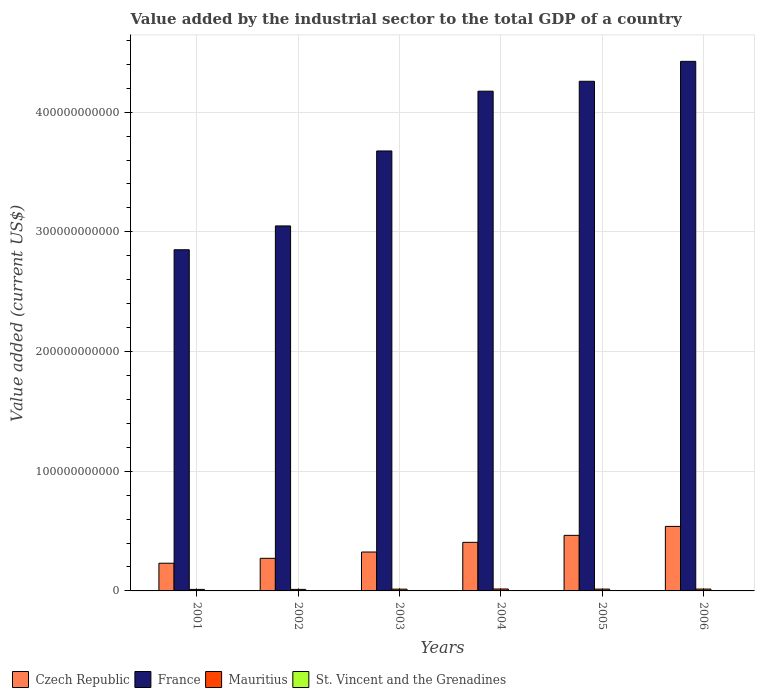How many different coloured bars are there?
Give a very brief answer. 4. What is the value added by the industrial sector to the total GDP in St. Vincent and the Grenadines in 2001?
Make the answer very short. 7.24e+07. Across all years, what is the maximum value added by the industrial sector to the total GDP in St. Vincent and the Grenadines?
Offer a very short reply. 1.00e+08. Across all years, what is the minimum value added by the industrial sector to the total GDP in Czech Republic?
Provide a succinct answer. 2.31e+1. What is the total value added by the industrial sector to the total GDP in Mauritius in the graph?
Ensure brevity in your answer.  8.70e+09. What is the difference between the value added by the industrial sector to the total GDP in Mauritius in 2005 and that in 2006?
Provide a succinct answer. -2.73e+07. What is the difference between the value added by the industrial sector to the total GDP in France in 2003 and the value added by the industrial sector to the total GDP in Czech Republic in 2004?
Ensure brevity in your answer.  3.27e+11. What is the average value added by the industrial sector to the total GDP in France per year?
Offer a very short reply. 3.74e+11. In the year 2002, what is the difference between the value added by the industrial sector to the total GDP in St. Vincent and the Grenadines and value added by the industrial sector to the total GDP in Mauritius?
Offer a very short reply. -1.21e+09. In how many years, is the value added by the industrial sector to the total GDP in Czech Republic greater than 40000000000 US$?
Your answer should be very brief. 3. What is the ratio of the value added by the industrial sector to the total GDP in Czech Republic in 2001 to that in 2004?
Keep it short and to the point. 0.57. What is the difference between the highest and the second highest value added by the industrial sector to the total GDP in Mauritius?
Make the answer very short. 7.12e+07. What is the difference between the highest and the lowest value added by the industrial sector to the total GDP in St. Vincent and the Grenadines?
Your answer should be very brief. 2.84e+07. Is the sum of the value added by the industrial sector to the total GDP in France in 2003 and 2005 greater than the maximum value added by the industrial sector to the total GDP in St. Vincent and the Grenadines across all years?
Keep it short and to the point. Yes. What does the 4th bar from the left in 2002 represents?
Your response must be concise. St. Vincent and the Grenadines. What does the 1st bar from the right in 2004 represents?
Your response must be concise. St. Vincent and the Grenadines. How many bars are there?
Provide a short and direct response. 24. What is the difference between two consecutive major ticks on the Y-axis?
Ensure brevity in your answer.  1.00e+11. Does the graph contain grids?
Provide a short and direct response. Yes. Where does the legend appear in the graph?
Ensure brevity in your answer.  Bottom left. How many legend labels are there?
Offer a very short reply. 4. What is the title of the graph?
Your response must be concise. Value added by the industrial sector to the total GDP of a country. Does "Bosnia and Herzegovina" appear as one of the legend labels in the graph?
Ensure brevity in your answer.  No. What is the label or title of the X-axis?
Offer a very short reply. Years. What is the label or title of the Y-axis?
Make the answer very short. Value added (current US$). What is the Value added (current US$) in Czech Republic in 2001?
Give a very brief answer. 2.31e+1. What is the Value added (current US$) in France in 2001?
Your response must be concise. 2.85e+11. What is the Value added (current US$) in Mauritius in 2001?
Offer a very short reply. 1.26e+09. What is the Value added (current US$) of St. Vincent and the Grenadines in 2001?
Offer a very short reply. 7.24e+07. What is the Value added (current US$) in Czech Republic in 2002?
Make the answer very short. 2.72e+1. What is the Value added (current US$) in France in 2002?
Your response must be concise. 3.05e+11. What is the Value added (current US$) in Mauritius in 2002?
Make the answer very short. 1.28e+09. What is the Value added (current US$) of St. Vincent and the Grenadines in 2002?
Keep it short and to the point. 7.20e+07. What is the Value added (current US$) in Czech Republic in 2003?
Ensure brevity in your answer.  3.25e+1. What is the Value added (current US$) of France in 2003?
Ensure brevity in your answer.  3.68e+11. What is the Value added (current US$) of Mauritius in 2003?
Your answer should be compact. 1.48e+09. What is the Value added (current US$) of St. Vincent and the Grenadines in 2003?
Give a very brief answer. 7.81e+07. What is the Value added (current US$) of Czech Republic in 2004?
Offer a very short reply. 4.06e+1. What is the Value added (current US$) of France in 2004?
Provide a short and direct response. 4.18e+11. What is the Value added (current US$) of Mauritius in 2004?
Give a very brief answer. 1.61e+09. What is the Value added (current US$) of St. Vincent and the Grenadines in 2004?
Provide a short and direct response. 8.77e+07. What is the Value added (current US$) of Czech Republic in 2005?
Provide a short and direct response. 4.64e+1. What is the Value added (current US$) of France in 2005?
Give a very brief answer. 4.26e+11. What is the Value added (current US$) in Mauritius in 2005?
Ensure brevity in your answer.  1.52e+09. What is the Value added (current US$) in St. Vincent and the Grenadines in 2005?
Give a very brief answer. 9.02e+07. What is the Value added (current US$) in Czech Republic in 2006?
Your response must be concise. 5.39e+1. What is the Value added (current US$) in France in 2006?
Offer a very short reply. 4.42e+11. What is the Value added (current US$) of Mauritius in 2006?
Offer a terse response. 1.54e+09. What is the Value added (current US$) in St. Vincent and the Grenadines in 2006?
Give a very brief answer. 1.00e+08. Across all years, what is the maximum Value added (current US$) in Czech Republic?
Make the answer very short. 5.39e+1. Across all years, what is the maximum Value added (current US$) in France?
Provide a succinct answer. 4.42e+11. Across all years, what is the maximum Value added (current US$) of Mauritius?
Offer a terse response. 1.61e+09. Across all years, what is the maximum Value added (current US$) in St. Vincent and the Grenadines?
Your answer should be very brief. 1.00e+08. Across all years, what is the minimum Value added (current US$) in Czech Republic?
Give a very brief answer. 2.31e+1. Across all years, what is the minimum Value added (current US$) in France?
Provide a succinct answer. 2.85e+11. Across all years, what is the minimum Value added (current US$) in Mauritius?
Provide a succinct answer. 1.26e+09. Across all years, what is the minimum Value added (current US$) of St. Vincent and the Grenadines?
Make the answer very short. 7.20e+07. What is the total Value added (current US$) in Czech Republic in the graph?
Your response must be concise. 2.24e+11. What is the total Value added (current US$) of France in the graph?
Provide a short and direct response. 2.24e+12. What is the total Value added (current US$) of Mauritius in the graph?
Your answer should be very brief. 8.70e+09. What is the total Value added (current US$) in St. Vincent and the Grenadines in the graph?
Offer a very short reply. 5.01e+08. What is the difference between the Value added (current US$) of Czech Republic in 2001 and that in 2002?
Give a very brief answer. -4.10e+09. What is the difference between the Value added (current US$) of France in 2001 and that in 2002?
Your response must be concise. -1.99e+1. What is the difference between the Value added (current US$) of Mauritius in 2001 and that in 2002?
Keep it short and to the point. -2.63e+07. What is the difference between the Value added (current US$) in St. Vincent and the Grenadines in 2001 and that in 2002?
Your answer should be compact. 4.23e+05. What is the difference between the Value added (current US$) in Czech Republic in 2001 and that in 2003?
Ensure brevity in your answer.  -9.36e+09. What is the difference between the Value added (current US$) in France in 2001 and that in 2003?
Your answer should be compact. -8.25e+1. What is the difference between the Value added (current US$) in Mauritius in 2001 and that in 2003?
Your response must be concise. -2.26e+08. What is the difference between the Value added (current US$) of St. Vincent and the Grenadines in 2001 and that in 2003?
Give a very brief answer. -5.65e+06. What is the difference between the Value added (current US$) in Czech Republic in 2001 and that in 2004?
Give a very brief answer. -1.75e+1. What is the difference between the Value added (current US$) in France in 2001 and that in 2004?
Provide a short and direct response. -1.32e+11. What is the difference between the Value added (current US$) in Mauritius in 2001 and that in 2004?
Your answer should be very brief. -3.57e+08. What is the difference between the Value added (current US$) in St. Vincent and the Grenadines in 2001 and that in 2004?
Offer a terse response. -1.53e+07. What is the difference between the Value added (current US$) in Czech Republic in 2001 and that in 2005?
Offer a very short reply. -2.33e+1. What is the difference between the Value added (current US$) in France in 2001 and that in 2005?
Make the answer very short. -1.41e+11. What is the difference between the Value added (current US$) in Mauritius in 2001 and that in 2005?
Provide a succinct answer. -2.58e+08. What is the difference between the Value added (current US$) of St. Vincent and the Grenadines in 2001 and that in 2005?
Ensure brevity in your answer.  -1.78e+07. What is the difference between the Value added (current US$) of Czech Republic in 2001 and that in 2006?
Provide a succinct answer. -3.08e+1. What is the difference between the Value added (current US$) of France in 2001 and that in 2006?
Give a very brief answer. -1.57e+11. What is the difference between the Value added (current US$) in Mauritius in 2001 and that in 2006?
Keep it short and to the point. -2.85e+08. What is the difference between the Value added (current US$) of St. Vincent and the Grenadines in 2001 and that in 2006?
Make the answer very short. -2.80e+07. What is the difference between the Value added (current US$) in Czech Republic in 2002 and that in 2003?
Make the answer very short. -5.26e+09. What is the difference between the Value added (current US$) in France in 2002 and that in 2003?
Keep it short and to the point. -6.26e+1. What is the difference between the Value added (current US$) of Mauritius in 2002 and that in 2003?
Provide a succinct answer. -1.99e+08. What is the difference between the Value added (current US$) of St. Vincent and the Grenadines in 2002 and that in 2003?
Your answer should be very brief. -6.07e+06. What is the difference between the Value added (current US$) in Czech Republic in 2002 and that in 2004?
Your answer should be very brief. -1.34e+1. What is the difference between the Value added (current US$) of France in 2002 and that in 2004?
Make the answer very short. -1.13e+11. What is the difference between the Value added (current US$) of Mauritius in 2002 and that in 2004?
Keep it short and to the point. -3.30e+08. What is the difference between the Value added (current US$) of St. Vincent and the Grenadines in 2002 and that in 2004?
Offer a very short reply. -1.57e+07. What is the difference between the Value added (current US$) of Czech Republic in 2002 and that in 2005?
Provide a short and direct response. -1.92e+1. What is the difference between the Value added (current US$) in France in 2002 and that in 2005?
Ensure brevity in your answer.  -1.21e+11. What is the difference between the Value added (current US$) in Mauritius in 2002 and that in 2005?
Your answer should be compact. -2.32e+08. What is the difference between the Value added (current US$) in St. Vincent and the Grenadines in 2002 and that in 2005?
Ensure brevity in your answer.  -1.82e+07. What is the difference between the Value added (current US$) of Czech Republic in 2002 and that in 2006?
Your answer should be compact. -2.67e+1. What is the difference between the Value added (current US$) of France in 2002 and that in 2006?
Ensure brevity in your answer.  -1.38e+11. What is the difference between the Value added (current US$) of Mauritius in 2002 and that in 2006?
Offer a very short reply. -2.59e+08. What is the difference between the Value added (current US$) in St. Vincent and the Grenadines in 2002 and that in 2006?
Make the answer very short. -2.84e+07. What is the difference between the Value added (current US$) in Czech Republic in 2003 and that in 2004?
Your answer should be very brief. -8.10e+09. What is the difference between the Value added (current US$) in France in 2003 and that in 2004?
Provide a succinct answer. -5.00e+1. What is the difference between the Value added (current US$) of Mauritius in 2003 and that in 2004?
Provide a succinct answer. -1.31e+08. What is the difference between the Value added (current US$) in St. Vincent and the Grenadines in 2003 and that in 2004?
Provide a short and direct response. -9.62e+06. What is the difference between the Value added (current US$) in Czech Republic in 2003 and that in 2005?
Provide a short and direct response. -1.39e+1. What is the difference between the Value added (current US$) in France in 2003 and that in 2005?
Your response must be concise. -5.82e+1. What is the difference between the Value added (current US$) in Mauritius in 2003 and that in 2005?
Your answer should be very brief. -3.26e+07. What is the difference between the Value added (current US$) of St. Vincent and the Grenadines in 2003 and that in 2005?
Provide a succinct answer. -1.21e+07. What is the difference between the Value added (current US$) in Czech Republic in 2003 and that in 2006?
Provide a short and direct response. -2.14e+1. What is the difference between the Value added (current US$) of France in 2003 and that in 2006?
Give a very brief answer. -7.49e+1. What is the difference between the Value added (current US$) in Mauritius in 2003 and that in 2006?
Provide a succinct answer. -5.99e+07. What is the difference between the Value added (current US$) of St. Vincent and the Grenadines in 2003 and that in 2006?
Ensure brevity in your answer.  -2.23e+07. What is the difference between the Value added (current US$) in Czech Republic in 2004 and that in 2005?
Your answer should be compact. -5.83e+09. What is the difference between the Value added (current US$) of France in 2004 and that in 2005?
Ensure brevity in your answer.  -8.28e+09. What is the difference between the Value added (current US$) of Mauritius in 2004 and that in 2005?
Your answer should be compact. 9.86e+07. What is the difference between the Value added (current US$) in St. Vincent and the Grenadines in 2004 and that in 2005?
Your response must be concise. -2.53e+06. What is the difference between the Value added (current US$) of Czech Republic in 2004 and that in 2006?
Your answer should be compact. -1.33e+1. What is the difference between the Value added (current US$) of France in 2004 and that in 2006?
Provide a short and direct response. -2.49e+1. What is the difference between the Value added (current US$) of Mauritius in 2004 and that in 2006?
Provide a succinct answer. 7.12e+07. What is the difference between the Value added (current US$) in St. Vincent and the Grenadines in 2004 and that in 2006?
Your response must be concise. -1.27e+07. What is the difference between the Value added (current US$) in Czech Republic in 2005 and that in 2006?
Provide a short and direct response. -7.49e+09. What is the difference between the Value added (current US$) of France in 2005 and that in 2006?
Offer a terse response. -1.66e+1. What is the difference between the Value added (current US$) of Mauritius in 2005 and that in 2006?
Your response must be concise. -2.73e+07. What is the difference between the Value added (current US$) of St. Vincent and the Grenadines in 2005 and that in 2006?
Provide a short and direct response. -1.02e+07. What is the difference between the Value added (current US$) of Czech Republic in 2001 and the Value added (current US$) of France in 2002?
Your response must be concise. -2.82e+11. What is the difference between the Value added (current US$) of Czech Republic in 2001 and the Value added (current US$) of Mauritius in 2002?
Offer a terse response. 2.19e+1. What is the difference between the Value added (current US$) of Czech Republic in 2001 and the Value added (current US$) of St. Vincent and the Grenadines in 2002?
Your answer should be very brief. 2.31e+1. What is the difference between the Value added (current US$) in France in 2001 and the Value added (current US$) in Mauritius in 2002?
Offer a terse response. 2.84e+11. What is the difference between the Value added (current US$) of France in 2001 and the Value added (current US$) of St. Vincent and the Grenadines in 2002?
Your answer should be compact. 2.85e+11. What is the difference between the Value added (current US$) of Mauritius in 2001 and the Value added (current US$) of St. Vincent and the Grenadines in 2002?
Ensure brevity in your answer.  1.19e+09. What is the difference between the Value added (current US$) of Czech Republic in 2001 and the Value added (current US$) of France in 2003?
Offer a terse response. -3.44e+11. What is the difference between the Value added (current US$) of Czech Republic in 2001 and the Value added (current US$) of Mauritius in 2003?
Give a very brief answer. 2.17e+1. What is the difference between the Value added (current US$) of Czech Republic in 2001 and the Value added (current US$) of St. Vincent and the Grenadines in 2003?
Your response must be concise. 2.31e+1. What is the difference between the Value added (current US$) in France in 2001 and the Value added (current US$) in Mauritius in 2003?
Offer a very short reply. 2.84e+11. What is the difference between the Value added (current US$) in France in 2001 and the Value added (current US$) in St. Vincent and the Grenadines in 2003?
Offer a very short reply. 2.85e+11. What is the difference between the Value added (current US$) in Mauritius in 2001 and the Value added (current US$) in St. Vincent and the Grenadines in 2003?
Give a very brief answer. 1.18e+09. What is the difference between the Value added (current US$) of Czech Republic in 2001 and the Value added (current US$) of France in 2004?
Give a very brief answer. -3.94e+11. What is the difference between the Value added (current US$) in Czech Republic in 2001 and the Value added (current US$) in Mauritius in 2004?
Make the answer very short. 2.15e+1. What is the difference between the Value added (current US$) of Czech Republic in 2001 and the Value added (current US$) of St. Vincent and the Grenadines in 2004?
Offer a very short reply. 2.31e+1. What is the difference between the Value added (current US$) in France in 2001 and the Value added (current US$) in Mauritius in 2004?
Your answer should be very brief. 2.83e+11. What is the difference between the Value added (current US$) of France in 2001 and the Value added (current US$) of St. Vincent and the Grenadines in 2004?
Offer a very short reply. 2.85e+11. What is the difference between the Value added (current US$) in Mauritius in 2001 and the Value added (current US$) in St. Vincent and the Grenadines in 2004?
Offer a terse response. 1.17e+09. What is the difference between the Value added (current US$) in Czech Republic in 2001 and the Value added (current US$) in France in 2005?
Provide a succinct answer. -4.03e+11. What is the difference between the Value added (current US$) in Czech Republic in 2001 and the Value added (current US$) in Mauritius in 2005?
Ensure brevity in your answer.  2.16e+1. What is the difference between the Value added (current US$) of Czech Republic in 2001 and the Value added (current US$) of St. Vincent and the Grenadines in 2005?
Offer a terse response. 2.31e+1. What is the difference between the Value added (current US$) of France in 2001 and the Value added (current US$) of Mauritius in 2005?
Offer a terse response. 2.84e+11. What is the difference between the Value added (current US$) in France in 2001 and the Value added (current US$) in St. Vincent and the Grenadines in 2005?
Offer a very short reply. 2.85e+11. What is the difference between the Value added (current US$) of Mauritius in 2001 and the Value added (current US$) of St. Vincent and the Grenadines in 2005?
Ensure brevity in your answer.  1.17e+09. What is the difference between the Value added (current US$) of Czech Republic in 2001 and the Value added (current US$) of France in 2006?
Offer a very short reply. -4.19e+11. What is the difference between the Value added (current US$) in Czech Republic in 2001 and the Value added (current US$) in Mauritius in 2006?
Ensure brevity in your answer.  2.16e+1. What is the difference between the Value added (current US$) in Czech Republic in 2001 and the Value added (current US$) in St. Vincent and the Grenadines in 2006?
Provide a succinct answer. 2.30e+1. What is the difference between the Value added (current US$) in France in 2001 and the Value added (current US$) in Mauritius in 2006?
Provide a short and direct response. 2.84e+11. What is the difference between the Value added (current US$) in France in 2001 and the Value added (current US$) in St. Vincent and the Grenadines in 2006?
Offer a terse response. 2.85e+11. What is the difference between the Value added (current US$) of Mauritius in 2001 and the Value added (current US$) of St. Vincent and the Grenadines in 2006?
Keep it short and to the point. 1.16e+09. What is the difference between the Value added (current US$) in Czech Republic in 2002 and the Value added (current US$) in France in 2003?
Ensure brevity in your answer.  -3.40e+11. What is the difference between the Value added (current US$) in Czech Republic in 2002 and the Value added (current US$) in Mauritius in 2003?
Your answer should be very brief. 2.58e+1. What is the difference between the Value added (current US$) in Czech Republic in 2002 and the Value added (current US$) in St. Vincent and the Grenadines in 2003?
Offer a very short reply. 2.72e+1. What is the difference between the Value added (current US$) in France in 2002 and the Value added (current US$) in Mauritius in 2003?
Your answer should be very brief. 3.03e+11. What is the difference between the Value added (current US$) of France in 2002 and the Value added (current US$) of St. Vincent and the Grenadines in 2003?
Ensure brevity in your answer.  3.05e+11. What is the difference between the Value added (current US$) in Mauritius in 2002 and the Value added (current US$) in St. Vincent and the Grenadines in 2003?
Provide a short and direct response. 1.21e+09. What is the difference between the Value added (current US$) in Czech Republic in 2002 and the Value added (current US$) in France in 2004?
Offer a terse response. -3.90e+11. What is the difference between the Value added (current US$) in Czech Republic in 2002 and the Value added (current US$) in Mauritius in 2004?
Your response must be concise. 2.56e+1. What is the difference between the Value added (current US$) of Czech Republic in 2002 and the Value added (current US$) of St. Vincent and the Grenadines in 2004?
Your answer should be very brief. 2.72e+1. What is the difference between the Value added (current US$) in France in 2002 and the Value added (current US$) in Mauritius in 2004?
Your answer should be very brief. 3.03e+11. What is the difference between the Value added (current US$) of France in 2002 and the Value added (current US$) of St. Vincent and the Grenadines in 2004?
Give a very brief answer. 3.05e+11. What is the difference between the Value added (current US$) of Mauritius in 2002 and the Value added (current US$) of St. Vincent and the Grenadines in 2004?
Keep it short and to the point. 1.20e+09. What is the difference between the Value added (current US$) of Czech Republic in 2002 and the Value added (current US$) of France in 2005?
Provide a short and direct response. -3.99e+11. What is the difference between the Value added (current US$) of Czech Republic in 2002 and the Value added (current US$) of Mauritius in 2005?
Provide a succinct answer. 2.57e+1. What is the difference between the Value added (current US$) in Czech Republic in 2002 and the Value added (current US$) in St. Vincent and the Grenadines in 2005?
Your response must be concise. 2.71e+1. What is the difference between the Value added (current US$) of France in 2002 and the Value added (current US$) of Mauritius in 2005?
Provide a succinct answer. 3.03e+11. What is the difference between the Value added (current US$) in France in 2002 and the Value added (current US$) in St. Vincent and the Grenadines in 2005?
Offer a terse response. 3.05e+11. What is the difference between the Value added (current US$) of Mauritius in 2002 and the Value added (current US$) of St. Vincent and the Grenadines in 2005?
Ensure brevity in your answer.  1.19e+09. What is the difference between the Value added (current US$) in Czech Republic in 2002 and the Value added (current US$) in France in 2006?
Your response must be concise. -4.15e+11. What is the difference between the Value added (current US$) of Czech Republic in 2002 and the Value added (current US$) of Mauritius in 2006?
Offer a very short reply. 2.57e+1. What is the difference between the Value added (current US$) in Czech Republic in 2002 and the Value added (current US$) in St. Vincent and the Grenadines in 2006?
Provide a succinct answer. 2.71e+1. What is the difference between the Value added (current US$) in France in 2002 and the Value added (current US$) in Mauritius in 2006?
Keep it short and to the point. 3.03e+11. What is the difference between the Value added (current US$) in France in 2002 and the Value added (current US$) in St. Vincent and the Grenadines in 2006?
Provide a short and direct response. 3.05e+11. What is the difference between the Value added (current US$) of Mauritius in 2002 and the Value added (current US$) of St. Vincent and the Grenadines in 2006?
Your response must be concise. 1.18e+09. What is the difference between the Value added (current US$) of Czech Republic in 2003 and the Value added (current US$) of France in 2004?
Your answer should be very brief. -3.85e+11. What is the difference between the Value added (current US$) in Czech Republic in 2003 and the Value added (current US$) in Mauritius in 2004?
Make the answer very short. 3.09e+1. What is the difference between the Value added (current US$) in Czech Republic in 2003 and the Value added (current US$) in St. Vincent and the Grenadines in 2004?
Provide a succinct answer. 3.24e+1. What is the difference between the Value added (current US$) of France in 2003 and the Value added (current US$) of Mauritius in 2004?
Provide a short and direct response. 3.66e+11. What is the difference between the Value added (current US$) of France in 2003 and the Value added (current US$) of St. Vincent and the Grenadines in 2004?
Keep it short and to the point. 3.68e+11. What is the difference between the Value added (current US$) of Mauritius in 2003 and the Value added (current US$) of St. Vincent and the Grenadines in 2004?
Ensure brevity in your answer.  1.40e+09. What is the difference between the Value added (current US$) of Czech Republic in 2003 and the Value added (current US$) of France in 2005?
Your answer should be compact. -3.93e+11. What is the difference between the Value added (current US$) in Czech Republic in 2003 and the Value added (current US$) in Mauritius in 2005?
Make the answer very short. 3.10e+1. What is the difference between the Value added (current US$) in Czech Republic in 2003 and the Value added (current US$) in St. Vincent and the Grenadines in 2005?
Make the answer very short. 3.24e+1. What is the difference between the Value added (current US$) in France in 2003 and the Value added (current US$) in Mauritius in 2005?
Keep it short and to the point. 3.66e+11. What is the difference between the Value added (current US$) in France in 2003 and the Value added (current US$) in St. Vincent and the Grenadines in 2005?
Ensure brevity in your answer.  3.68e+11. What is the difference between the Value added (current US$) of Mauritius in 2003 and the Value added (current US$) of St. Vincent and the Grenadines in 2005?
Make the answer very short. 1.39e+09. What is the difference between the Value added (current US$) of Czech Republic in 2003 and the Value added (current US$) of France in 2006?
Make the answer very short. -4.10e+11. What is the difference between the Value added (current US$) in Czech Republic in 2003 and the Value added (current US$) in Mauritius in 2006?
Provide a succinct answer. 3.10e+1. What is the difference between the Value added (current US$) in Czech Republic in 2003 and the Value added (current US$) in St. Vincent and the Grenadines in 2006?
Provide a succinct answer. 3.24e+1. What is the difference between the Value added (current US$) of France in 2003 and the Value added (current US$) of Mauritius in 2006?
Offer a terse response. 3.66e+11. What is the difference between the Value added (current US$) of France in 2003 and the Value added (current US$) of St. Vincent and the Grenadines in 2006?
Ensure brevity in your answer.  3.67e+11. What is the difference between the Value added (current US$) in Mauritius in 2003 and the Value added (current US$) in St. Vincent and the Grenadines in 2006?
Provide a short and direct response. 1.38e+09. What is the difference between the Value added (current US$) in Czech Republic in 2004 and the Value added (current US$) in France in 2005?
Give a very brief answer. -3.85e+11. What is the difference between the Value added (current US$) in Czech Republic in 2004 and the Value added (current US$) in Mauritius in 2005?
Provide a short and direct response. 3.91e+1. What is the difference between the Value added (current US$) of Czech Republic in 2004 and the Value added (current US$) of St. Vincent and the Grenadines in 2005?
Provide a succinct answer. 4.05e+1. What is the difference between the Value added (current US$) in France in 2004 and the Value added (current US$) in Mauritius in 2005?
Your answer should be very brief. 4.16e+11. What is the difference between the Value added (current US$) in France in 2004 and the Value added (current US$) in St. Vincent and the Grenadines in 2005?
Give a very brief answer. 4.17e+11. What is the difference between the Value added (current US$) in Mauritius in 2004 and the Value added (current US$) in St. Vincent and the Grenadines in 2005?
Keep it short and to the point. 1.52e+09. What is the difference between the Value added (current US$) in Czech Republic in 2004 and the Value added (current US$) in France in 2006?
Your response must be concise. -4.02e+11. What is the difference between the Value added (current US$) in Czech Republic in 2004 and the Value added (current US$) in Mauritius in 2006?
Provide a short and direct response. 3.91e+1. What is the difference between the Value added (current US$) in Czech Republic in 2004 and the Value added (current US$) in St. Vincent and the Grenadines in 2006?
Provide a succinct answer. 4.05e+1. What is the difference between the Value added (current US$) of France in 2004 and the Value added (current US$) of Mauritius in 2006?
Offer a terse response. 4.16e+11. What is the difference between the Value added (current US$) in France in 2004 and the Value added (current US$) in St. Vincent and the Grenadines in 2006?
Give a very brief answer. 4.17e+11. What is the difference between the Value added (current US$) in Mauritius in 2004 and the Value added (current US$) in St. Vincent and the Grenadines in 2006?
Your answer should be very brief. 1.51e+09. What is the difference between the Value added (current US$) of Czech Republic in 2005 and the Value added (current US$) of France in 2006?
Offer a very short reply. -3.96e+11. What is the difference between the Value added (current US$) in Czech Republic in 2005 and the Value added (current US$) in Mauritius in 2006?
Keep it short and to the point. 4.49e+1. What is the difference between the Value added (current US$) in Czech Republic in 2005 and the Value added (current US$) in St. Vincent and the Grenadines in 2006?
Keep it short and to the point. 4.63e+1. What is the difference between the Value added (current US$) of France in 2005 and the Value added (current US$) of Mauritius in 2006?
Your answer should be very brief. 4.24e+11. What is the difference between the Value added (current US$) in France in 2005 and the Value added (current US$) in St. Vincent and the Grenadines in 2006?
Provide a short and direct response. 4.26e+11. What is the difference between the Value added (current US$) of Mauritius in 2005 and the Value added (current US$) of St. Vincent and the Grenadines in 2006?
Your answer should be compact. 1.42e+09. What is the average Value added (current US$) of Czech Republic per year?
Give a very brief answer. 3.73e+1. What is the average Value added (current US$) in France per year?
Offer a very short reply. 3.74e+11. What is the average Value added (current US$) of Mauritius per year?
Your answer should be compact. 1.45e+09. What is the average Value added (current US$) of St. Vincent and the Grenadines per year?
Your response must be concise. 8.35e+07. In the year 2001, what is the difference between the Value added (current US$) in Czech Republic and Value added (current US$) in France?
Offer a very short reply. -2.62e+11. In the year 2001, what is the difference between the Value added (current US$) of Czech Republic and Value added (current US$) of Mauritius?
Make the answer very short. 2.19e+1. In the year 2001, what is the difference between the Value added (current US$) of Czech Republic and Value added (current US$) of St. Vincent and the Grenadines?
Offer a terse response. 2.31e+1. In the year 2001, what is the difference between the Value added (current US$) of France and Value added (current US$) of Mauritius?
Your answer should be compact. 2.84e+11. In the year 2001, what is the difference between the Value added (current US$) in France and Value added (current US$) in St. Vincent and the Grenadines?
Provide a succinct answer. 2.85e+11. In the year 2001, what is the difference between the Value added (current US$) of Mauritius and Value added (current US$) of St. Vincent and the Grenadines?
Keep it short and to the point. 1.19e+09. In the year 2002, what is the difference between the Value added (current US$) of Czech Republic and Value added (current US$) of France?
Ensure brevity in your answer.  -2.78e+11. In the year 2002, what is the difference between the Value added (current US$) of Czech Republic and Value added (current US$) of Mauritius?
Your answer should be compact. 2.60e+1. In the year 2002, what is the difference between the Value added (current US$) in Czech Republic and Value added (current US$) in St. Vincent and the Grenadines?
Offer a terse response. 2.72e+1. In the year 2002, what is the difference between the Value added (current US$) in France and Value added (current US$) in Mauritius?
Provide a succinct answer. 3.04e+11. In the year 2002, what is the difference between the Value added (current US$) of France and Value added (current US$) of St. Vincent and the Grenadines?
Keep it short and to the point. 3.05e+11. In the year 2002, what is the difference between the Value added (current US$) in Mauritius and Value added (current US$) in St. Vincent and the Grenadines?
Your response must be concise. 1.21e+09. In the year 2003, what is the difference between the Value added (current US$) of Czech Republic and Value added (current US$) of France?
Your answer should be compact. -3.35e+11. In the year 2003, what is the difference between the Value added (current US$) of Czech Republic and Value added (current US$) of Mauritius?
Make the answer very short. 3.10e+1. In the year 2003, what is the difference between the Value added (current US$) in Czech Republic and Value added (current US$) in St. Vincent and the Grenadines?
Provide a short and direct response. 3.24e+1. In the year 2003, what is the difference between the Value added (current US$) of France and Value added (current US$) of Mauritius?
Provide a succinct answer. 3.66e+11. In the year 2003, what is the difference between the Value added (current US$) of France and Value added (current US$) of St. Vincent and the Grenadines?
Your answer should be compact. 3.68e+11. In the year 2003, what is the difference between the Value added (current US$) in Mauritius and Value added (current US$) in St. Vincent and the Grenadines?
Provide a succinct answer. 1.41e+09. In the year 2004, what is the difference between the Value added (current US$) of Czech Republic and Value added (current US$) of France?
Your answer should be very brief. -3.77e+11. In the year 2004, what is the difference between the Value added (current US$) of Czech Republic and Value added (current US$) of Mauritius?
Your response must be concise. 3.90e+1. In the year 2004, what is the difference between the Value added (current US$) of Czech Republic and Value added (current US$) of St. Vincent and the Grenadines?
Offer a very short reply. 4.05e+1. In the year 2004, what is the difference between the Value added (current US$) of France and Value added (current US$) of Mauritius?
Your answer should be compact. 4.16e+11. In the year 2004, what is the difference between the Value added (current US$) in France and Value added (current US$) in St. Vincent and the Grenadines?
Ensure brevity in your answer.  4.17e+11. In the year 2004, what is the difference between the Value added (current US$) of Mauritius and Value added (current US$) of St. Vincent and the Grenadines?
Give a very brief answer. 1.53e+09. In the year 2005, what is the difference between the Value added (current US$) of Czech Republic and Value added (current US$) of France?
Provide a succinct answer. -3.79e+11. In the year 2005, what is the difference between the Value added (current US$) in Czech Republic and Value added (current US$) in Mauritius?
Provide a short and direct response. 4.49e+1. In the year 2005, what is the difference between the Value added (current US$) in Czech Republic and Value added (current US$) in St. Vincent and the Grenadines?
Your answer should be compact. 4.63e+1. In the year 2005, what is the difference between the Value added (current US$) of France and Value added (current US$) of Mauritius?
Your answer should be compact. 4.24e+11. In the year 2005, what is the difference between the Value added (current US$) in France and Value added (current US$) in St. Vincent and the Grenadines?
Provide a succinct answer. 4.26e+11. In the year 2005, what is the difference between the Value added (current US$) of Mauritius and Value added (current US$) of St. Vincent and the Grenadines?
Provide a short and direct response. 1.43e+09. In the year 2006, what is the difference between the Value added (current US$) in Czech Republic and Value added (current US$) in France?
Provide a short and direct response. -3.89e+11. In the year 2006, what is the difference between the Value added (current US$) in Czech Republic and Value added (current US$) in Mauritius?
Make the answer very short. 5.24e+1. In the year 2006, what is the difference between the Value added (current US$) in Czech Republic and Value added (current US$) in St. Vincent and the Grenadines?
Provide a succinct answer. 5.38e+1. In the year 2006, what is the difference between the Value added (current US$) in France and Value added (current US$) in Mauritius?
Offer a very short reply. 4.41e+11. In the year 2006, what is the difference between the Value added (current US$) of France and Value added (current US$) of St. Vincent and the Grenadines?
Give a very brief answer. 4.42e+11. In the year 2006, what is the difference between the Value added (current US$) of Mauritius and Value added (current US$) of St. Vincent and the Grenadines?
Provide a short and direct response. 1.44e+09. What is the ratio of the Value added (current US$) in Czech Republic in 2001 to that in 2002?
Give a very brief answer. 0.85. What is the ratio of the Value added (current US$) of France in 2001 to that in 2002?
Keep it short and to the point. 0.93. What is the ratio of the Value added (current US$) of Mauritius in 2001 to that in 2002?
Your response must be concise. 0.98. What is the ratio of the Value added (current US$) of St. Vincent and the Grenadines in 2001 to that in 2002?
Give a very brief answer. 1.01. What is the ratio of the Value added (current US$) in Czech Republic in 2001 to that in 2003?
Your answer should be very brief. 0.71. What is the ratio of the Value added (current US$) of France in 2001 to that in 2003?
Provide a short and direct response. 0.78. What is the ratio of the Value added (current US$) of Mauritius in 2001 to that in 2003?
Provide a short and direct response. 0.85. What is the ratio of the Value added (current US$) in St. Vincent and the Grenadines in 2001 to that in 2003?
Offer a very short reply. 0.93. What is the ratio of the Value added (current US$) in Czech Republic in 2001 to that in 2004?
Your answer should be very brief. 0.57. What is the ratio of the Value added (current US$) of France in 2001 to that in 2004?
Your response must be concise. 0.68. What is the ratio of the Value added (current US$) of Mauritius in 2001 to that in 2004?
Offer a very short reply. 0.78. What is the ratio of the Value added (current US$) in St. Vincent and the Grenadines in 2001 to that in 2004?
Your answer should be compact. 0.83. What is the ratio of the Value added (current US$) in Czech Republic in 2001 to that in 2005?
Your response must be concise. 0.5. What is the ratio of the Value added (current US$) in France in 2001 to that in 2005?
Make the answer very short. 0.67. What is the ratio of the Value added (current US$) in Mauritius in 2001 to that in 2005?
Make the answer very short. 0.83. What is the ratio of the Value added (current US$) in St. Vincent and the Grenadines in 2001 to that in 2005?
Offer a very short reply. 0.8. What is the ratio of the Value added (current US$) of Czech Republic in 2001 to that in 2006?
Your response must be concise. 0.43. What is the ratio of the Value added (current US$) of France in 2001 to that in 2006?
Make the answer very short. 0.64. What is the ratio of the Value added (current US$) in Mauritius in 2001 to that in 2006?
Ensure brevity in your answer.  0.82. What is the ratio of the Value added (current US$) of St. Vincent and the Grenadines in 2001 to that in 2006?
Make the answer very short. 0.72. What is the ratio of the Value added (current US$) of Czech Republic in 2002 to that in 2003?
Your response must be concise. 0.84. What is the ratio of the Value added (current US$) of France in 2002 to that in 2003?
Your answer should be very brief. 0.83. What is the ratio of the Value added (current US$) of Mauritius in 2002 to that in 2003?
Your answer should be compact. 0.87. What is the ratio of the Value added (current US$) of St. Vincent and the Grenadines in 2002 to that in 2003?
Give a very brief answer. 0.92. What is the ratio of the Value added (current US$) of Czech Republic in 2002 to that in 2004?
Provide a short and direct response. 0.67. What is the ratio of the Value added (current US$) of France in 2002 to that in 2004?
Ensure brevity in your answer.  0.73. What is the ratio of the Value added (current US$) of Mauritius in 2002 to that in 2004?
Offer a terse response. 0.8. What is the ratio of the Value added (current US$) of St. Vincent and the Grenadines in 2002 to that in 2004?
Keep it short and to the point. 0.82. What is the ratio of the Value added (current US$) in Czech Republic in 2002 to that in 2005?
Your answer should be very brief. 0.59. What is the ratio of the Value added (current US$) in France in 2002 to that in 2005?
Ensure brevity in your answer.  0.72. What is the ratio of the Value added (current US$) in Mauritius in 2002 to that in 2005?
Offer a terse response. 0.85. What is the ratio of the Value added (current US$) in St. Vincent and the Grenadines in 2002 to that in 2005?
Your answer should be compact. 0.8. What is the ratio of the Value added (current US$) of Czech Republic in 2002 to that in 2006?
Provide a short and direct response. 0.51. What is the ratio of the Value added (current US$) in France in 2002 to that in 2006?
Your response must be concise. 0.69. What is the ratio of the Value added (current US$) in Mauritius in 2002 to that in 2006?
Keep it short and to the point. 0.83. What is the ratio of the Value added (current US$) in St. Vincent and the Grenadines in 2002 to that in 2006?
Your response must be concise. 0.72. What is the ratio of the Value added (current US$) of Czech Republic in 2003 to that in 2004?
Provide a short and direct response. 0.8. What is the ratio of the Value added (current US$) of France in 2003 to that in 2004?
Provide a short and direct response. 0.88. What is the ratio of the Value added (current US$) of Mauritius in 2003 to that in 2004?
Your response must be concise. 0.92. What is the ratio of the Value added (current US$) in St. Vincent and the Grenadines in 2003 to that in 2004?
Offer a very short reply. 0.89. What is the ratio of the Value added (current US$) of France in 2003 to that in 2005?
Keep it short and to the point. 0.86. What is the ratio of the Value added (current US$) in Mauritius in 2003 to that in 2005?
Make the answer very short. 0.98. What is the ratio of the Value added (current US$) in St. Vincent and the Grenadines in 2003 to that in 2005?
Provide a succinct answer. 0.87. What is the ratio of the Value added (current US$) in Czech Republic in 2003 to that in 2006?
Your answer should be very brief. 0.6. What is the ratio of the Value added (current US$) of France in 2003 to that in 2006?
Offer a very short reply. 0.83. What is the ratio of the Value added (current US$) of Mauritius in 2003 to that in 2006?
Provide a short and direct response. 0.96. What is the ratio of the Value added (current US$) of St. Vincent and the Grenadines in 2003 to that in 2006?
Your answer should be compact. 0.78. What is the ratio of the Value added (current US$) of Czech Republic in 2004 to that in 2005?
Offer a terse response. 0.87. What is the ratio of the Value added (current US$) in France in 2004 to that in 2005?
Your response must be concise. 0.98. What is the ratio of the Value added (current US$) of Mauritius in 2004 to that in 2005?
Your answer should be very brief. 1.06. What is the ratio of the Value added (current US$) of Czech Republic in 2004 to that in 2006?
Provide a succinct answer. 0.75. What is the ratio of the Value added (current US$) of France in 2004 to that in 2006?
Your answer should be very brief. 0.94. What is the ratio of the Value added (current US$) of Mauritius in 2004 to that in 2006?
Give a very brief answer. 1.05. What is the ratio of the Value added (current US$) of St. Vincent and the Grenadines in 2004 to that in 2006?
Your answer should be compact. 0.87. What is the ratio of the Value added (current US$) of Czech Republic in 2005 to that in 2006?
Your answer should be compact. 0.86. What is the ratio of the Value added (current US$) in France in 2005 to that in 2006?
Provide a succinct answer. 0.96. What is the ratio of the Value added (current US$) in Mauritius in 2005 to that in 2006?
Your answer should be very brief. 0.98. What is the ratio of the Value added (current US$) of St. Vincent and the Grenadines in 2005 to that in 2006?
Give a very brief answer. 0.9. What is the difference between the highest and the second highest Value added (current US$) in Czech Republic?
Provide a short and direct response. 7.49e+09. What is the difference between the highest and the second highest Value added (current US$) of France?
Ensure brevity in your answer.  1.66e+1. What is the difference between the highest and the second highest Value added (current US$) in Mauritius?
Offer a terse response. 7.12e+07. What is the difference between the highest and the second highest Value added (current US$) of St. Vincent and the Grenadines?
Give a very brief answer. 1.02e+07. What is the difference between the highest and the lowest Value added (current US$) of Czech Republic?
Offer a terse response. 3.08e+1. What is the difference between the highest and the lowest Value added (current US$) in France?
Your answer should be compact. 1.57e+11. What is the difference between the highest and the lowest Value added (current US$) of Mauritius?
Keep it short and to the point. 3.57e+08. What is the difference between the highest and the lowest Value added (current US$) in St. Vincent and the Grenadines?
Your answer should be compact. 2.84e+07. 